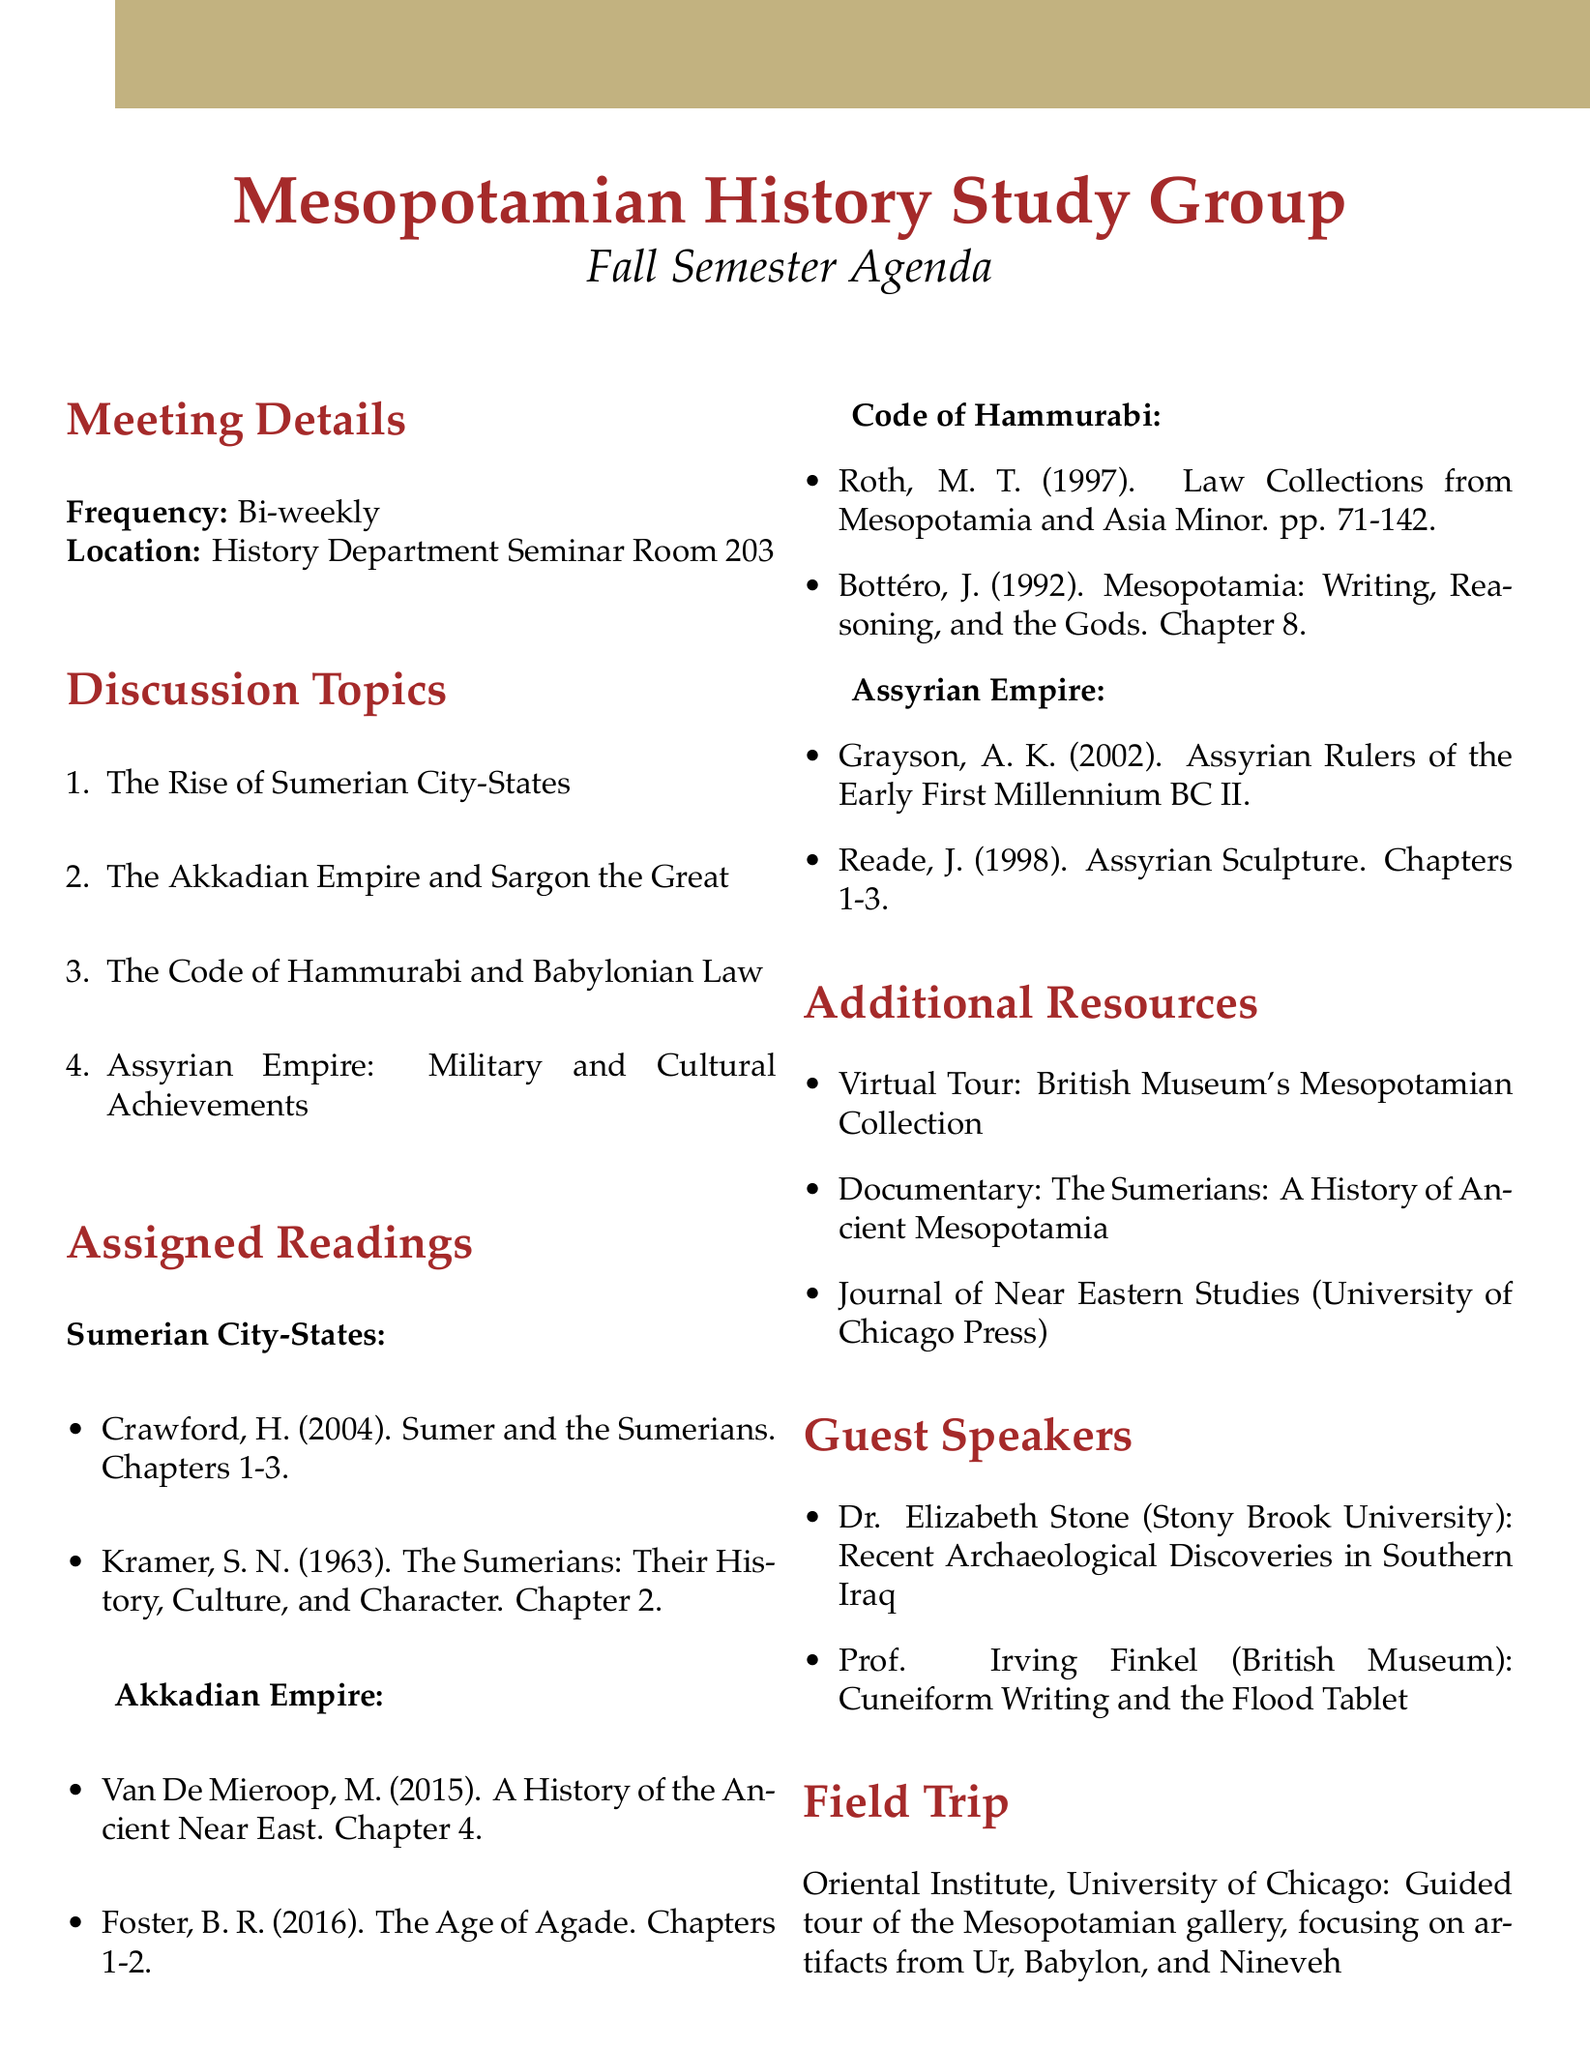What is the frequency of the meetings? The frequency of the meetings is mentioned directly in the document under "Meeting Details."
Answer: Bi-weekly Where will the meetings be held? The location of the meetings is specified in the "Meeting Details" section.
Answer: History Department Seminar Room 203 Who is the guest speaker discussing recent archaeological discoveries? The name of the guest speaker and their topic is provided in the "Guest Speakers" section of the document.
Answer: Dr. Elizabeth Stone What is one of the assigned readings for the topic on the Akkadian Empire? The assigned readings for different topics are listed in connection to each subject under "Assigned Readings."
Answer: Van De Mieroop, M. (2015). A History of the Ancient Near East, ca. 3000-323 BC. Chapter 4 Which city is the focus of the guided tour for the field trip? The document describes the field trip and the destination focused on specific artifacts.
Answer: Chicago What is one of the subtopics related to the Code of Hammurabi? The subtopics for each discussion topic are listed to elaborate on the topics under "Discussion Topics."
Answer: Social classes and justice in Babylonian society How many discussion topics are there? The total number of discussion topics can be counted from the "Discussion Topics" list.
Answer: Four What type of additional resource is the "Journal of Near Eastern Studies"? The type of additional resource is explained in the "Additional Resources" section of the document.
Answer: Academic Journal 